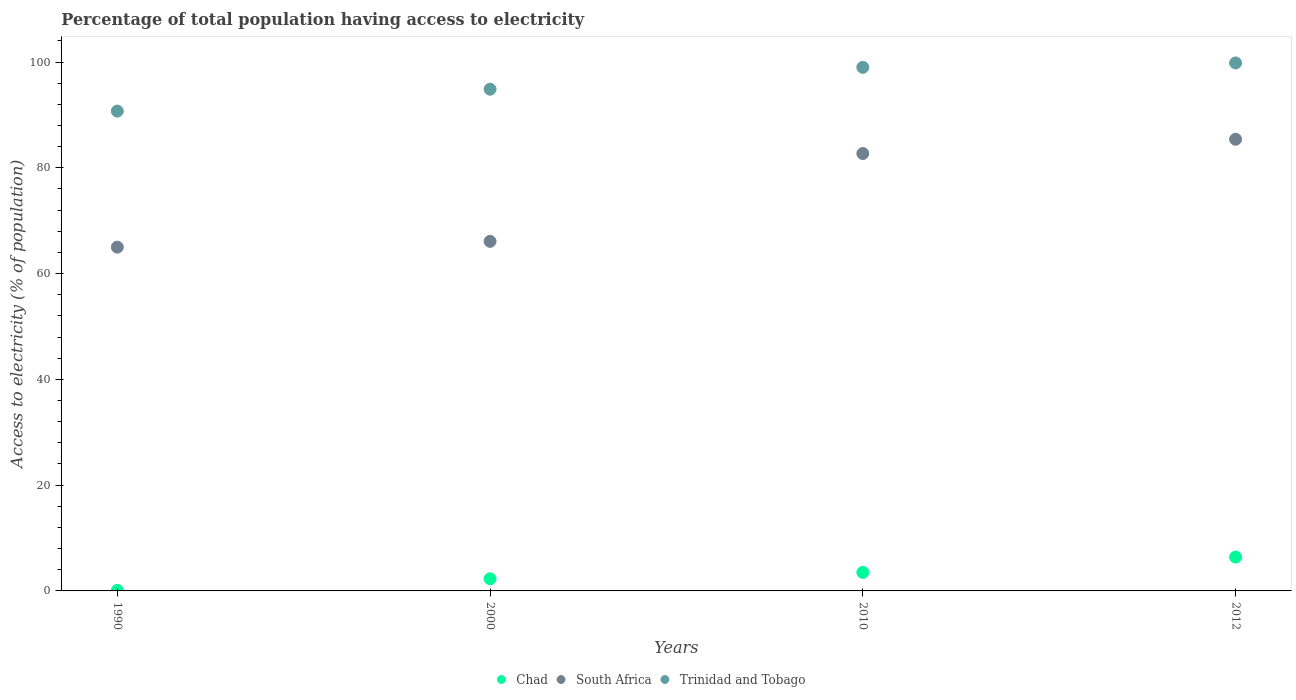What is the percentage of population that have access to electricity in Trinidad and Tobago in 2010?
Offer a very short reply. 99. Across all years, what is the maximum percentage of population that have access to electricity in South Africa?
Your answer should be compact. 85.4. Across all years, what is the minimum percentage of population that have access to electricity in Trinidad and Tobago?
Make the answer very short. 90.72. In which year was the percentage of population that have access to electricity in Chad maximum?
Ensure brevity in your answer.  2012. In which year was the percentage of population that have access to electricity in Chad minimum?
Ensure brevity in your answer.  1990. What is the total percentage of population that have access to electricity in South Africa in the graph?
Give a very brief answer. 299.2. What is the difference between the percentage of population that have access to electricity in Chad in 2010 and that in 2012?
Your answer should be compact. -2.9. What is the difference between the percentage of population that have access to electricity in Trinidad and Tobago in 2000 and the percentage of population that have access to electricity in Chad in 2012?
Your answer should be very brief. 88.46. What is the average percentage of population that have access to electricity in Trinidad and Tobago per year?
Offer a very short reply. 96.1. In the year 2010, what is the difference between the percentage of population that have access to electricity in Chad and percentage of population that have access to electricity in Trinidad and Tobago?
Offer a very short reply. -95.5. In how many years, is the percentage of population that have access to electricity in Chad greater than 4 %?
Ensure brevity in your answer.  1. What is the ratio of the percentage of population that have access to electricity in South Africa in 1990 to that in 2010?
Make the answer very short. 0.79. Is the percentage of population that have access to electricity in Trinidad and Tobago in 1990 less than that in 2010?
Your answer should be very brief. Yes. What is the difference between the highest and the second highest percentage of population that have access to electricity in Chad?
Your response must be concise. 2.9. What is the difference between the highest and the lowest percentage of population that have access to electricity in Chad?
Your response must be concise. 6.3. Is the sum of the percentage of population that have access to electricity in South Africa in 1990 and 2000 greater than the maximum percentage of population that have access to electricity in Chad across all years?
Offer a very short reply. Yes. How many dotlines are there?
Keep it short and to the point. 3. Does the graph contain any zero values?
Ensure brevity in your answer.  No. Where does the legend appear in the graph?
Your answer should be compact. Bottom center. What is the title of the graph?
Your answer should be compact. Percentage of total population having access to electricity. Does "Ecuador" appear as one of the legend labels in the graph?
Give a very brief answer. No. What is the label or title of the Y-axis?
Provide a short and direct response. Access to electricity (% of population). What is the Access to electricity (% of population) of South Africa in 1990?
Your answer should be very brief. 65. What is the Access to electricity (% of population) of Trinidad and Tobago in 1990?
Your response must be concise. 90.72. What is the Access to electricity (% of population) of Chad in 2000?
Give a very brief answer. 2.3. What is the Access to electricity (% of population) of South Africa in 2000?
Provide a short and direct response. 66.1. What is the Access to electricity (% of population) of Trinidad and Tobago in 2000?
Your response must be concise. 94.86. What is the Access to electricity (% of population) of South Africa in 2010?
Give a very brief answer. 82.7. What is the Access to electricity (% of population) in South Africa in 2012?
Your answer should be compact. 85.4. What is the Access to electricity (% of population) in Trinidad and Tobago in 2012?
Your response must be concise. 99.83. Across all years, what is the maximum Access to electricity (% of population) of South Africa?
Provide a short and direct response. 85.4. Across all years, what is the maximum Access to electricity (% of population) of Trinidad and Tobago?
Your answer should be compact. 99.83. Across all years, what is the minimum Access to electricity (% of population) in Chad?
Your answer should be very brief. 0.1. Across all years, what is the minimum Access to electricity (% of population) of Trinidad and Tobago?
Your answer should be very brief. 90.72. What is the total Access to electricity (% of population) of Chad in the graph?
Provide a succinct answer. 12.3. What is the total Access to electricity (% of population) in South Africa in the graph?
Provide a succinct answer. 299.2. What is the total Access to electricity (% of population) in Trinidad and Tobago in the graph?
Ensure brevity in your answer.  384.41. What is the difference between the Access to electricity (% of population) of Trinidad and Tobago in 1990 and that in 2000?
Give a very brief answer. -4.14. What is the difference between the Access to electricity (% of population) of Chad in 1990 and that in 2010?
Your answer should be compact. -3.4. What is the difference between the Access to electricity (% of population) of South Africa in 1990 and that in 2010?
Your answer should be compact. -17.7. What is the difference between the Access to electricity (% of population) in Trinidad and Tobago in 1990 and that in 2010?
Your answer should be compact. -8.28. What is the difference between the Access to electricity (% of population) in South Africa in 1990 and that in 2012?
Offer a very short reply. -20.4. What is the difference between the Access to electricity (% of population) of Trinidad and Tobago in 1990 and that in 2012?
Give a very brief answer. -9.11. What is the difference between the Access to electricity (% of population) of South Africa in 2000 and that in 2010?
Provide a succinct answer. -16.6. What is the difference between the Access to electricity (% of population) of Trinidad and Tobago in 2000 and that in 2010?
Your response must be concise. -4.14. What is the difference between the Access to electricity (% of population) of South Africa in 2000 and that in 2012?
Provide a short and direct response. -19.3. What is the difference between the Access to electricity (% of population) of Trinidad and Tobago in 2000 and that in 2012?
Your answer should be compact. -4.97. What is the difference between the Access to electricity (% of population) of Chad in 2010 and that in 2012?
Make the answer very short. -2.9. What is the difference between the Access to electricity (% of population) of Trinidad and Tobago in 2010 and that in 2012?
Your response must be concise. -0.83. What is the difference between the Access to electricity (% of population) of Chad in 1990 and the Access to electricity (% of population) of South Africa in 2000?
Your response must be concise. -66. What is the difference between the Access to electricity (% of population) in Chad in 1990 and the Access to electricity (% of population) in Trinidad and Tobago in 2000?
Give a very brief answer. -94.76. What is the difference between the Access to electricity (% of population) of South Africa in 1990 and the Access to electricity (% of population) of Trinidad and Tobago in 2000?
Offer a terse response. -29.86. What is the difference between the Access to electricity (% of population) in Chad in 1990 and the Access to electricity (% of population) in South Africa in 2010?
Make the answer very short. -82.6. What is the difference between the Access to electricity (% of population) of Chad in 1990 and the Access to electricity (% of population) of Trinidad and Tobago in 2010?
Give a very brief answer. -98.9. What is the difference between the Access to electricity (% of population) of South Africa in 1990 and the Access to electricity (% of population) of Trinidad and Tobago in 2010?
Provide a short and direct response. -34. What is the difference between the Access to electricity (% of population) in Chad in 1990 and the Access to electricity (% of population) in South Africa in 2012?
Your answer should be very brief. -85.3. What is the difference between the Access to electricity (% of population) of Chad in 1990 and the Access to electricity (% of population) of Trinidad and Tobago in 2012?
Make the answer very short. -99.73. What is the difference between the Access to electricity (% of population) in South Africa in 1990 and the Access to electricity (% of population) in Trinidad and Tobago in 2012?
Make the answer very short. -34.83. What is the difference between the Access to electricity (% of population) of Chad in 2000 and the Access to electricity (% of population) of South Africa in 2010?
Make the answer very short. -80.4. What is the difference between the Access to electricity (% of population) of Chad in 2000 and the Access to electricity (% of population) of Trinidad and Tobago in 2010?
Keep it short and to the point. -96.7. What is the difference between the Access to electricity (% of population) in South Africa in 2000 and the Access to electricity (% of population) in Trinidad and Tobago in 2010?
Give a very brief answer. -32.9. What is the difference between the Access to electricity (% of population) in Chad in 2000 and the Access to electricity (% of population) in South Africa in 2012?
Provide a succinct answer. -83.1. What is the difference between the Access to electricity (% of population) of Chad in 2000 and the Access to electricity (% of population) of Trinidad and Tobago in 2012?
Provide a short and direct response. -97.53. What is the difference between the Access to electricity (% of population) in South Africa in 2000 and the Access to electricity (% of population) in Trinidad and Tobago in 2012?
Keep it short and to the point. -33.73. What is the difference between the Access to electricity (% of population) of Chad in 2010 and the Access to electricity (% of population) of South Africa in 2012?
Make the answer very short. -81.9. What is the difference between the Access to electricity (% of population) of Chad in 2010 and the Access to electricity (% of population) of Trinidad and Tobago in 2012?
Your answer should be very brief. -96.33. What is the difference between the Access to electricity (% of population) of South Africa in 2010 and the Access to electricity (% of population) of Trinidad and Tobago in 2012?
Keep it short and to the point. -17.13. What is the average Access to electricity (% of population) of Chad per year?
Give a very brief answer. 3.08. What is the average Access to electricity (% of population) of South Africa per year?
Your answer should be compact. 74.8. What is the average Access to electricity (% of population) in Trinidad and Tobago per year?
Provide a succinct answer. 96.1. In the year 1990, what is the difference between the Access to electricity (% of population) in Chad and Access to electricity (% of population) in South Africa?
Offer a very short reply. -64.9. In the year 1990, what is the difference between the Access to electricity (% of population) of Chad and Access to electricity (% of population) of Trinidad and Tobago?
Your answer should be very brief. -90.62. In the year 1990, what is the difference between the Access to electricity (% of population) of South Africa and Access to electricity (% of population) of Trinidad and Tobago?
Give a very brief answer. -25.72. In the year 2000, what is the difference between the Access to electricity (% of population) in Chad and Access to electricity (% of population) in South Africa?
Provide a succinct answer. -63.8. In the year 2000, what is the difference between the Access to electricity (% of population) of Chad and Access to electricity (% of population) of Trinidad and Tobago?
Your answer should be compact. -92.56. In the year 2000, what is the difference between the Access to electricity (% of population) of South Africa and Access to electricity (% of population) of Trinidad and Tobago?
Give a very brief answer. -28.76. In the year 2010, what is the difference between the Access to electricity (% of population) in Chad and Access to electricity (% of population) in South Africa?
Ensure brevity in your answer.  -79.2. In the year 2010, what is the difference between the Access to electricity (% of population) of Chad and Access to electricity (% of population) of Trinidad and Tobago?
Give a very brief answer. -95.5. In the year 2010, what is the difference between the Access to electricity (% of population) of South Africa and Access to electricity (% of population) of Trinidad and Tobago?
Ensure brevity in your answer.  -16.3. In the year 2012, what is the difference between the Access to electricity (% of population) of Chad and Access to electricity (% of population) of South Africa?
Give a very brief answer. -79. In the year 2012, what is the difference between the Access to electricity (% of population) in Chad and Access to electricity (% of population) in Trinidad and Tobago?
Provide a short and direct response. -93.43. In the year 2012, what is the difference between the Access to electricity (% of population) of South Africa and Access to electricity (% of population) of Trinidad and Tobago?
Your answer should be compact. -14.43. What is the ratio of the Access to electricity (% of population) of Chad in 1990 to that in 2000?
Provide a succinct answer. 0.04. What is the ratio of the Access to electricity (% of population) of South Africa in 1990 to that in 2000?
Offer a very short reply. 0.98. What is the ratio of the Access to electricity (% of population) of Trinidad and Tobago in 1990 to that in 2000?
Make the answer very short. 0.96. What is the ratio of the Access to electricity (% of population) of Chad in 1990 to that in 2010?
Make the answer very short. 0.03. What is the ratio of the Access to electricity (% of population) of South Africa in 1990 to that in 2010?
Your answer should be compact. 0.79. What is the ratio of the Access to electricity (% of population) of Trinidad and Tobago in 1990 to that in 2010?
Keep it short and to the point. 0.92. What is the ratio of the Access to electricity (% of population) in Chad in 1990 to that in 2012?
Ensure brevity in your answer.  0.02. What is the ratio of the Access to electricity (% of population) in South Africa in 1990 to that in 2012?
Your response must be concise. 0.76. What is the ratio of the Access to electricity (% of population) in Trinidad and Tobago in 1990 to that in 2012?
Make the answer very short. 0.91. What is the ratio of the Access to electricity (% of population) in Chad in 2000 to that in 2010?
Ensure brevity in your answer.  0.66. What is the ratio of the Access to electricity (% of population) in South Africa in 2000 to that in 2010?
Keep it short and to the point. 0.8. What is the ratio of the Access to electricity (% of population) in Trinidad and Tobago in 2000 to that in 2010?
Make the answer very short. 0.96. What is the ratio of the Access to electricity (% of population) in Chad in 2000 to that in 2012?
Make the answer very short. 0.36. What is the ratio of the Access to electricity (% of population) in South Africa in 2000 to that in 2012?
Your answer should be very brief. 0.77. What is the ratio of the Access to electricity (% of population) of Trinidad and Tobago in 2000 to that in 2012?
Give a very brief answer. 0.95. What is the ratio of the Access to electricity (% of population) of Chad in 2010 to that in 2012?
Make the answer very short. 0.55. What is the ratio of the Access to electricity (% of population) of South Africa in 2010 to that in 2012?
Offer a terse response. 0.97. What is the difference between the highest and the second highest Access to electricity (% of population) of Chad?
Your response must be concise. 2.9. What is the difference between the highest and the second highest Access to electricity (% of population) of Trinidad and Tobago?
Provide a short and direct response. 0.83. What is the difference between the highest and the lowest Access to electricity (% of population) of South Africa?
Make the answer very short. 20.4. What is the difference between the highest and the lowest Access to electricity (% of population) in Trinidad and Tobago?
Your answer should be compact. 9.11. 